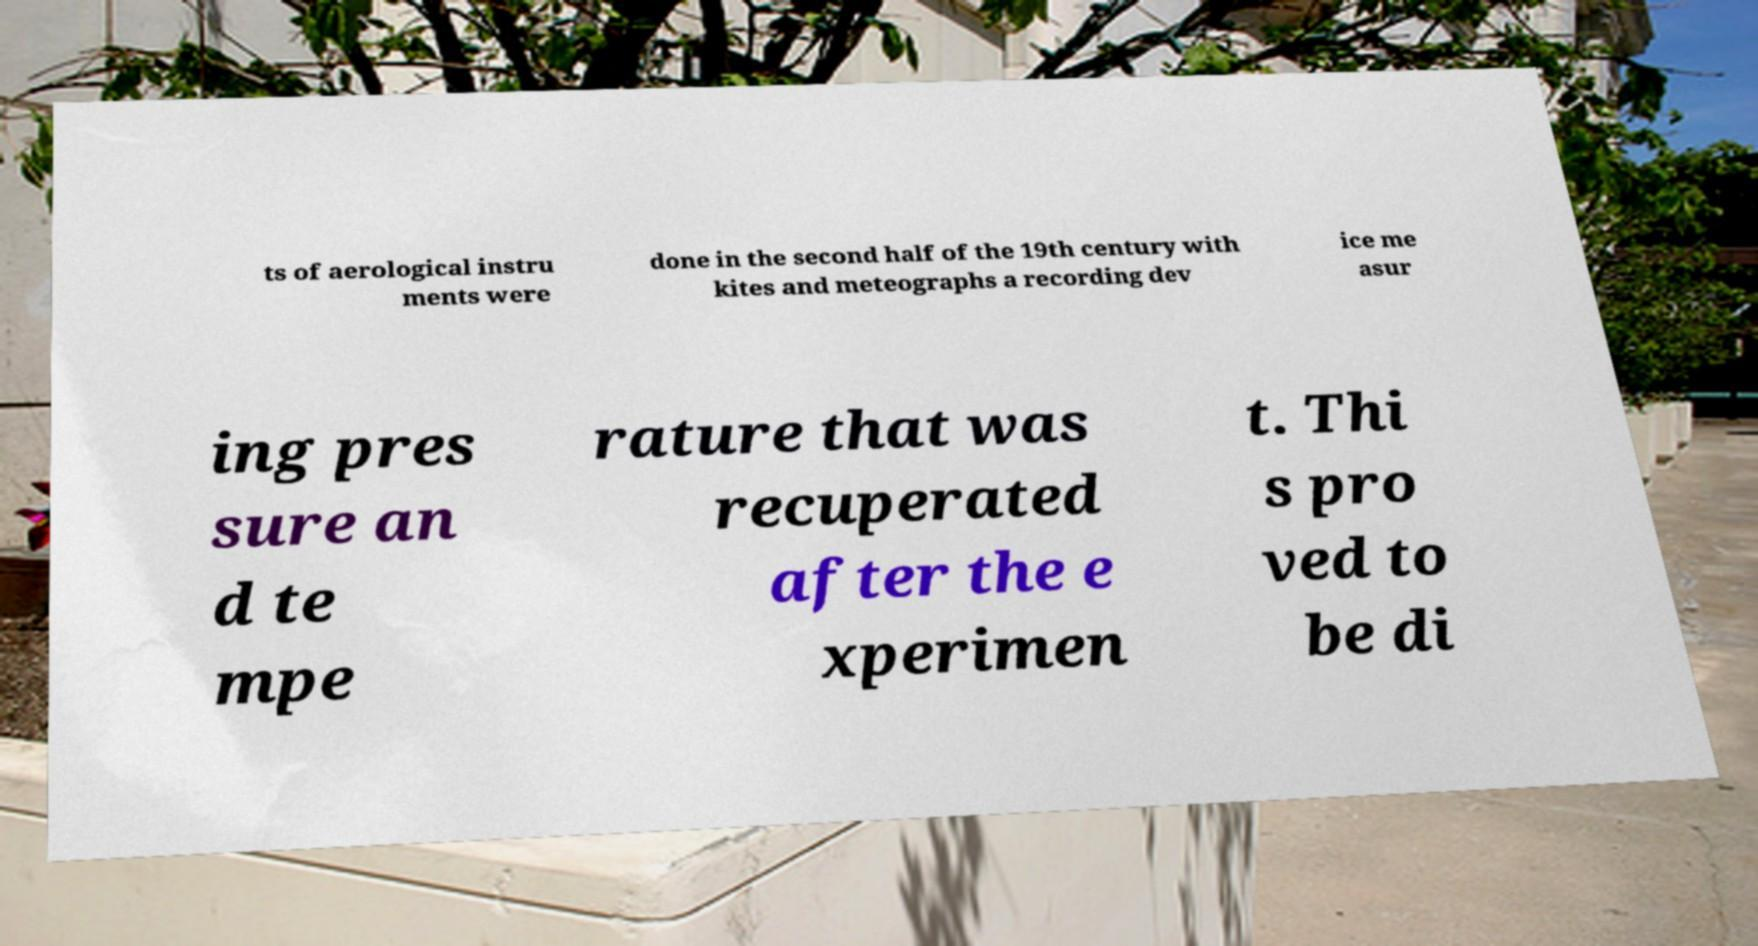For documentation purposes, I need the text within this image transcribed. Could you provide that? ts of aerological instru ments were done in the second half of the 19th century with kites and meteographs a recording dev ice me asur ing pres sure an d te mpe rature that was recuperated after the e xperimen t. Thi s pro ved to be di 